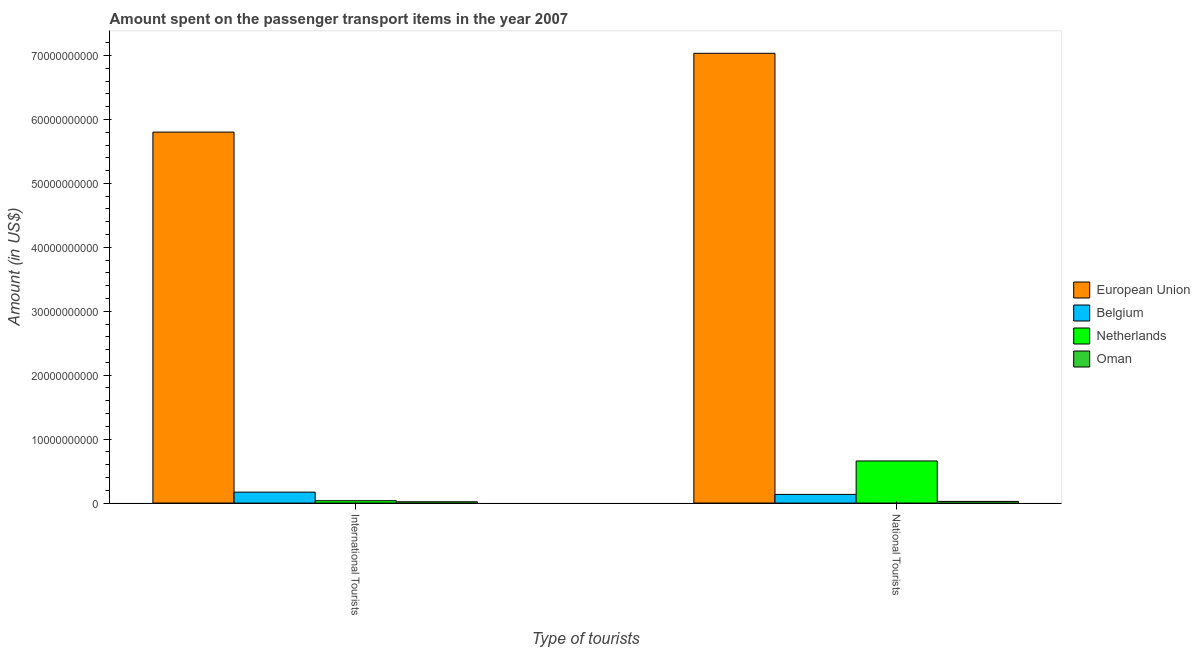How many groups of bars are there?
Ensure brevity in your answer.  2. What is the label of the 2nd group of bars from the left?
Make the answer very short. National Tourists. What is the amount spent on transport items of national tourists in Netherlands?
Offer a terse response. 6.58e+09. Across all countries, what is the maximum amount spent on transport items of national tourists?
Your answer should be compact. 7.04e+1. Across all countries, what is the minimum amount spent on transport items of national tourists?
Keep it short and to the point. 2.57e+08. In which country was the amount spent on transport items of national tourists maximum?
Your response must be concise. European Union. In which country was the amount spent on transport items of international tourists minimum?
Provide a short and direct response. Oman. What is the total amount spent on transport items of national tourists in the graph?
Provide a short and direct response. 7.85e+1. What is the difference between the amount spent on transport items of national tourists in Netherlands and that in European Union?
Provide a succinct answer. -6.38e+1. What is the difference between the amount spent on transport items of international tourists in Belgium and the amount spent on transport items of national tourists in Oman?
Offer a terse response. 1.45e+09. What is the average amount spent on transport items of international tourists per country?
Your answer should be very brief. 1.51e+1. What is the difference between the amount spent on transport items of national tourists and amount spent on transport items of international tourists in Oman?
Ensure brevity in your answer.  5.70e+07. In how many countries, is the amount spent on transport items of national tourists greater than 50000000000 US$?
Offer a very short reply. 1. What is the ratio of the amount spent on transport items of international tourists in European Union to that in Oman?
Give a very brief answer. 290.14. In how many countries, is the amount spent on transport items of national tourists greater than the average amount spent on transport items of national tourists taken over all countries?
Make the answer very short. 1. What does the 1st bar from the left in International Tourists represents?
Provide a short and direct response. European Union. What does the 2nd bar from the right in National Tourists represents?
Provide a succinct answer. Netherlands. What is the difference between two consecutive major ticks on the Y-axis?
Offer a terse response. 1.00e+1. Are the values on the major ticks of Y-axis written in scientific E-notation?
Offer a terse response. No. Where does the legend appear in the graph?
Make the answer very short. Center right. What is the title of the graph?
Provide a succinct answer. Amount spent on the passenger transport items in the year 2007. Does "Greenland" appear as one of the legend labels in the graph?
Provide a succinct answer. No. What is the label or title of the X-axis?
Make the answer very short. Type of tourists. What is the label or title of the Y-axis?
Offer a terse response. Amount (in US$). What is the Amount (in US$) of European Union in International Tourists?
Your answer should be compact. 5.80e+1. What is the Amount (in US$) in Belgium in International Tourists?
Provide a succinct answer. 1.71e+09. What is the Amount (in US$) of Netherlands in International Tourists?
Offer a terse response. 3.67e+08. What is the Amount (in US$) of Oman in International Tourists?
Your answer should be very brief. 2.00e+08. What is the Amount (in US$) in European Union in National Tourists?
Keep it short and to the point. 7.04e+1. What is the Amount (in US$) of Belgium in National Tourists?
Offer a terse response. 1.35e+09. What is the Amount (in US$) in Netherlands in National Tourists?
Offer a terse response. 6.58e+09. What is the Amount (in US$) of Oman in National Tourists?
Your answer should be compact. 2.57e+08. Across all Type of tourists, what is the maximum Amount (in US$) of European Union?
Keep it short and to the point. 7.04e+1. Across all Type of tourists, what is the maximum Amount (in US$) in Belgium?
Your response must be concise. 1.71e+09. Across all Type of tourists, what is the maximum Amount (in US$) in Netherlands?
Provide a succinct answer. 6.58e+09. Across all Type of tourists, what is the maximum Amount (in US$) of Oman?
Make the answer very short. 2.57e+08. Across all Type of tourists, what is the minimum Amount (in US$) of European Union?
Ensure brevity in your answer.  5.80e+1. Across all Type of tourists, what is the minimum Amount (in US$) of Belgium?
Offer a very short reply. 1.35e+09. Across all Type of tourists, what is the minimum Amount (in US$) in Netherlands?
Provide a succinct answer. 3.67e+08. Across all Type of tourists, what is the minimum Amount (in US$) of Oman?
Your answer should be compact. 2.00e+08. What is the total Amount (in US$) in European Union in the graph?
Make the answer very short. 1.28e+11. What is the total Amount (in US$) in Belgium in the graph?
Give a very brief answer. 3.06e+09. What is the total Amount (in US$) of Netherlands in the graph?
Keep it short and to the point. 6.95e+09. What is the total Amount (in US$) of Oman in the graph?
Your response must be concise. 4.57e+08. What is the difference between the Amount (in US$) in European Union in International Tourists and that in National Tourists?
Provide a succinct answer. -1.23e+1. What is the difference between the Amount (in US$) in Belgium in International Tourists and that in National Tourists?
Keep it short and to the point. 3.55e+08. What is the difference between the Amount (in US$) in Netherlands in International Tourists and that in National Tourists?
Your answer should be very brief. -6.22e+09. What is the difference between the Amount (in US$) in Oman in International Tourists and that in National Tourists?
Ensure brevity in your answer.  -5.70e+07. What is the difference between the Amount (in US$) of European Union in International Tourists and the Amount (in US$) of Belgium in National Tourists?
Your answer should be very brief. 5.67e+1. What is the difference between the Amount (in US$) of European Union in International Tourists and the Amount (in US$) of Netherlands in National Tourists?
Offer a terse response. 5.14e+1. What is the difference between the Amount (in US$) of European Union in International Tourists and the Amount (in US$) of Oman in National Tourists?
Provide a short and direct response. 5.78e+1. What is the difference between the Amount (in US$) of Belgium in International Tourists and the Amount (in US$) of Netherlands in National Tourists?
Offer a terse response. -4.87e+09. What is the difference between the Amount (in US$) in Belgium in International Tourists and the Amount (in US$) in Oman in National Tourists?
Give a very brief answer. 1.45e+09. What is the difference between the Amount (in US$) in Netherlands in International Tourists and the Amount (in US$) in Oman in National Tourists?
Your answer should be very brief. 1.10e+08. What is the average Amount (in US$) of European Union per Type of tourists?
Your answer should be very brief. 6.42e+1. What is the average Amount (in US$) of Belgium per Type of tourists?
Provide a short and direct response. 1.53e+09. What is the average Amount (in US$) of Netherlands per Type of tourists?
Offer a very short reply. 3.48e+09. What is the average Amount (in US$) in Oman per Type of tourists?
Offer a very short reply. 2.28e+08. What is the difference between the Amount (in US$) in European Union and Amount (in US$) in Belgium in International Tourists?
Your answer should be compact. 5.63e+1. What is the difference between the Amount (in US$) in European Union and Amount (in US$) in Netherlands in International Tourists?
Your response must be concise. 5.77e+1. What is the difference between the Amount (in US$) of European Union and Amount (in US$) of Oman in International Tourists?
Your response must be concise. 5.78e+1. What is the difference between the Amount (in US$) of Belgium and Amount (in US$) of Netherlands in International Tourists?
Ensure brevity in your answer.  1.34e+09. What is the difference between the Amount (in US$) in Belgium and Amount (in US$) in Oman in International Tourists?
Your answer should be very brief. 1.51e+09. What is the difference between the Amount (in US$) of Netherlands and Amount (in US$) of Oman in International Tourists?
Offer a very short reply. 1.67e+08. What is the difference between the Amount (in US$) in European Union and Amount (in US$) in Belgium in National Tourists?
Offer a very short reply. 6.90e+1. What is the difference between the Amount (in US$) of European Union and Amount (in US$) of Netherlands in National Tourists?
Offer a terse response. 6.38e+1. What is the difference between the Amount (in US$) of European Union and Amount (in US$) of Oman in National Tourists?
Keep it short and to the point. 7.01e+1. What is the difference between the Amount (in US$) in Belgium and Amount (in US$) in Netherlands in National Tourists?
Your answer should be compact. -5.23e+09. What is the difference between the Amount (in US$) of Belgium and Amount (in US$) of Oman in National Tourists?
Provide a succinct answer. 1.10e+09. What is the difference between the Amount (in US$) of Netherlands and Amount (in US$) of Oman in National Tourists?
Keep it short and to the point. 6.33e+09. What is the ratio of the Amount (in US$) of European Union in International Tourists to that in National Tourists?
Provide a short and direct response. 0.82. What is the ratio of the Amount (in US$) of Belgium in International Tourists to that in National Tourists?
Ensure brevity in your answer.  1.26. What is the ratio of the Amount (in US$) of Netherlands in International Tourists to that in National Tourists?
Give a very brief answer. 0.06. What is the ratio of the Amount (in US$) in Oman in International Tourists to that in National Tourists?
Provide a succinct answer. 0.78. What is the difference between the highest and the second highest Amount (in US$) of European Union?
Your answer should be very brief. 1.23e+1. What is the difference between the highest and the second highest Amount (in US$) of Belgium?
Offer a terse response. 3.55e+08. What is the difference between the highest and the second highest Amount (in US$) of Netherlands?
Your answer should be very brief. 6.22e+09. What is the difference between the highest and the second highest Amount (in US$) of Oman?
Keep it short and to the point. 5.70e+07. What is the difference between the highest and the lowest Amount (in US$) in European Union?
Provide a short and direct response. 1.23e+1. What is the difference between the highest and the lowest Amount (in US$) in Belgium?
Your answer should be compact. 3.55e+08. What is the difference between the highest and the lowest Amount (in US$) in Netherlands?
Provide a short and direct response. 6.22e+09. What is the difference between the highest and the lowest Amount (in US$) of Oman?
Provide a short and direct response. 5.70e+07. 